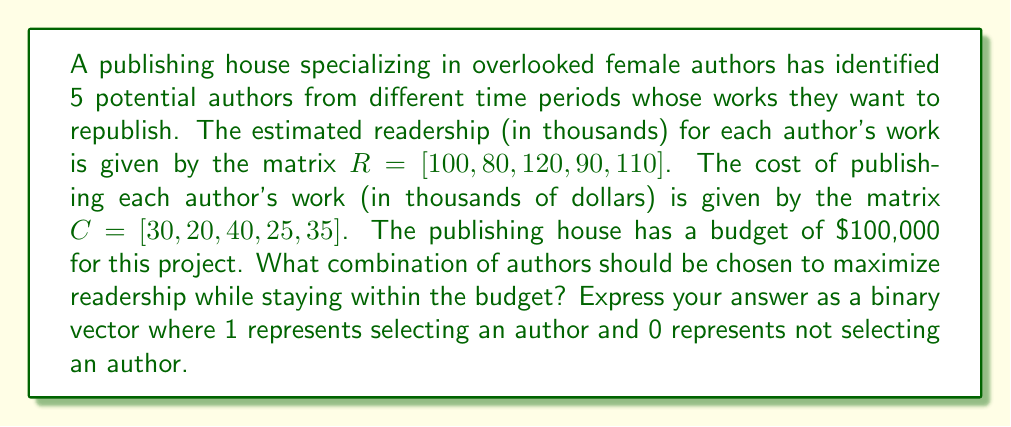Solve this math problem. This problem can be solved using integer programming, specifically the 0-1 knapsack problem. Let's approach this step-by-step:

1) First, we need to define our decision variables. Let $x_i$ be a binary variable where:
   $x_i = \begin{cases} 1 & \text{if author i is selected} \\ 0 & \text{if author i is not selected} \end{cases}$

2) Our objective function is to maximize readership:
   $\text{Maximize } \sum_{i=1}^5 R_i x_i = 100x_1 + 80x_2 + 120x_3 + 90x_4 + 110x_5$

3) Our constraint is the budget:
   $\sum_{i=1}^5 C_i x_i \leq 100$
   $30x_1 + 20x_2 + 40x_3 + 25x_4 + 35x_5 \leq 100$

4) We can solve this using the branch and bound method, but for simplicity, let's evaluate all possible combinations:

   $[1,1,1,1,1]$ - Cost: 150, Readership: 500 (Over budget)
   $[1,1,1,1,0]$ - Cost: 115, Readership: 390 (Over budget)
   $[1,1,1,0,1]$ - Cost: 125, Readership: 410 (Over budget)
   $[1,1,1,0,0]$ - Cost: 90, Readership: 300
   $[1,1,0,1,1]$ - Cost: 110, Readership: 380 (Over budget)
   $[1,1,0,1,0]$ - Cost: 75, Readership: 270
   $[1,1,0,0,1]$ - Cost: 85, Readership: 290
   $[1,0,1,1,1]$ - Cost: 130, Readership: 420 (Over budget)
   $[1,0,1,1,0]$ - Cost: 95, Readership: 310
   $[1,0,1,0,1]$ - Cost: 105, Readership: 330 (Over budget)
   $[1,0,0,1,1]$ - Cost: 90, Readership: 300
   $[0,1,1,1,1]$ - Cost: 120, Readership: 400 (Over budget)
   $[0,1,1,1,0]$ - Cost: 85, Readership: 290
   $[0,1,1,0,1]$ - Cost: 95, Readership: 310
   $[0,1,0,1,1]$ - Cost: 80, Readership: 280
   $[0,0,1,1,1]$ - Cost: 100, Readership: 320

5) From these combinations, we can see that $[1,0,1,1,0]$ gives the maximum readership of 310,000 while staying within the budget.
Answer: $[1,0,1,1,0]$ 